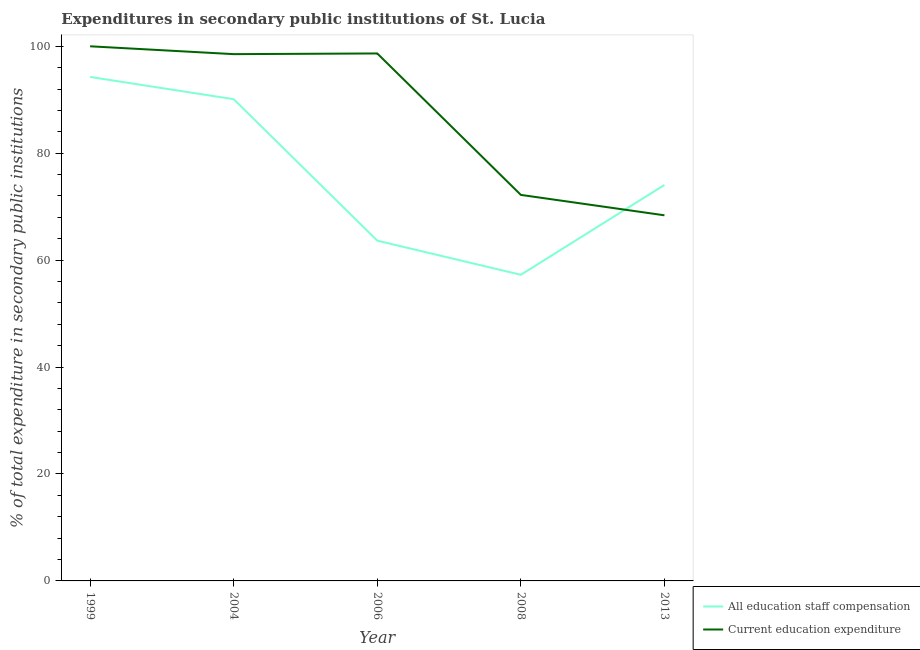How many different coloured lines are there?
Offer a very short reply. 2. Does the line corresponding to expenditure in education intersect with the line corresponding to expenditure in staff compensation?
Provide a succinct answer. Yes. What is the expenditure in education in 2008?
Your answer should be very brief. 72.2. Across all years, what is the maximum expenditure in staff compensation?
Offer a terse response. 94.27. Across all years, what is the minimum expenditure in staff compensation?
Provide a succinct answer. 57.26. In which year was the expenditure in education maximum?
Offer a terse response. 1999. What is the total expenditure in education in the graph?
Offer a terse response. 437.79. What is the difference between the expenditure in staff compensation in 1999 and that in 2013?
Provide a short and direct response. 20.2. What is the difference between the expenditure in education in 1999 and the expenditure in staff compensation in 2004?
Your answer should be very brief. 9.9. What is the average expenditure in staff compensation per year?
Your answer should be very brief. 75.87. In the year 2004, what is the difference between the expenditure in education and expenditure in staff compensation?
Provide a succinct answer. 8.43. What is the ratio of the expenditure in staff compensation in 1999 to that in 2013?
Make the answer very short. 1.27. Is the expenditure in staff compensation in 1999 less than that in 2013?
Keep it short and to the point. No. Is the difference between the expenditure in staff compensation in 1999 and 2008 greater than the difference between the expenditure in education in 1999 and 2008?
Give a very brief answer. Yes. What is the difference between the highest and the second highest expenditure in education?
Make the answer very short. 1.34. What is the difference between the highest and the lowest expenditure in staff compensation?
Your response must be concise. 37. Is the sum of the expenditure in education in 1999 and 2006 greater than the maximum expenditure in staff compensation across all years?
Your response must be concise. Yes. Is the expenditure in staff compensation strictly greater than the expenditure in education over the years?
Give a very brief answer. No. Is the expenditure in education strictly less than the expenditure in staff compensation over the years?
Make the answer very short. No. What is the difference between two consecutive major ticks on the Y-axis?
Offer a terse response. 20. Are the values on the major ticks of Y-axis written in scientific E-notation?
Offer a very short reply. No. Where does the legend appear in the graph?
Your response must be concise. Bottom right. How many legend labels are there?
Your response must be concise. 2. How are the legend labels stacked?
Your answer should be very brief. Vertical. What is the title of the graph?
Offer a very short reply. Expenditures in secondary public institutions of St. Lucia. Does "Adolescent fertility rate" appear as one of the legend labels in the graph?
Offer a very short reply. No. What is the label or title of the Y-axis?
Keep it short and to the point. % of total expenditure in secondary public institutions. What is the % of total expenditure in secondary public institutions of All education staff compensation in 1999?
Your answer should be very brief. 94.27. What is the % of total expenditure in secondary public institutions of All education staff compensation in 2004?
Your answer should be very brief. 90.1. What is the % of total expenditure in secondary public institutions in Current education expenditure in 2004?
Ensure brevity in your answer.  98.53. What is the % of total expenditure in secondary public institutions of All education staff compensation in 2006?
Your response must be concise. 63.64. What is the % of total expenditure in secondary public institutions of Current education expenditure in 2006?
Offer a very short reply. 98.66. What is the % of total expenditure in secondary public institutions of All education staff compensation in 2008?
Your answer should be compact. 57.26. What is the % of total expenditure in secondary public institutions in Current education expenditure in 2008?
Give a very brief answer. 72.2. What is the % of total expenditure in secondary public institutions in All education staff compensation in 2013?
Keep it short and to the point. 74.07. What is the % of total expenditure in secondary public institutions in Current education expenditure in 2013?
Your response must be concise. 68.39. Across all years, what is the maximum % of total expenditure in secondary public institutions in All education staff compensation?
Provide a succinct answer. 94.27. Across all years, what is the minimum % of total expenditure in secondary public institutions in All education staff compensation?
Ensure brevity in your answer.  57.26. Across all years, what is the minimum % of total expenditure in secondary public institutions in Current education expenditure?
Your response must be concise. 68.39. What is the total % of total expenditure in secondary public institutions in All education staff compensation in the graph?
Provide a succinct answer. 379.35. What is the total % of total expenditure in secondary public institutions in Current education expenditure in the graph?
Ensure brevity in your answer.  437.79. What is the difference between the % of total expenditure in secondary public institutions of All education staff compensation in 1999 and that in 2004?
Your answer should be compact. 4.16. What is the difference between the % of total expenditure in secondary public institutions of Current education expenditure in 1999 and that in 2004?
Keep it short and to the point. 1.47. What is the difference between the % of total expenditure in secondary public institutions of All education staff compensation in 1999 and that in 2006?
Offer a very short reply. 30.62. What is the difference between the % of total expenditure in secondary public institutions of Current education expenditure in 1999 and that in 2006?
Offer a terse response. 1.34. What is the difference between the % of total expenditure in secondary public institutions in All education staff compensation in 1999 and that in 2008?
Ensure brevity in your answer.  37. What is the difference between the % of total expenditure in secondary public institutions in Current education expenditure in 1999 and that in 2008?
Offer a very short reply. 27.8. What is the difference between the % of total expenditure in secondary public institutions of All education staff compensation in 1999 and that in 2013?
Provide a short and direct response. 20.2. What is the difference between the % of total expenditure in secondary public institutions in Current education expenditure in 1999 and that in 2013?
Ensure brevity in your answer.  31.61. What is the difference between the % of total expenditure in secondary public institutions in All education staff compensation in 2004 and that in 2006?
Your answer should be compact. 26.46. What is the difference between the % of total expenditure in secondary public institutions in Current education expenditure in 2004 and that in 2006?
Offer a terse response. -0.13. What is the difference between the % of total expenditure in secondary public institutions in All education staff compensation in 2004 and that in 2008?
Give a very brief answer. 32.84. What is the difference between the % of total expenditure in secondary public institutions of Current education expenditure in 2004 and that in 2008?
Offer a very short reply. 26.33. What is the difference between the % of total expenditure in secondary public institutions of All education staff compensation in 2004 and that in 2013?
Give a very brief answer. 16.04. What is the difference between the % of total expenditure in secondary public institutions of Current education expenditure in 2004 and that in 2013?
Provide a succinct answer. 30.14. What is the difference between the % of total expenditure in secondary public institutions of All education staff compensation in 2006 and that in 2008?
Offer a terse response. 6.38. What is the difference between the % of total expenditure in secondary public institutions of Current education expenditure in 2006 and that in 2008?
Make the answer very short. 26.46. What is the difference between the % of total expenditure in secondary public institutions in All education staff compensation in 2006 and that in 2013?
Your answer should be very brief. -10.42. What is the difference between the % of total expenditure in secondary public institutions in Current education expenditure in 2006 and that in 2013?
Your answer should be very brief. 30.27. What is the difference between the % of total expenditure in secondary public institutions in All education staff compensation in 2008 and that in 2013?
Your response must be concise. -16.8. What is the difference between the % of total expenditure in secondary public institutions of Current education expenditure in 2008 and that in 2013?
Provide a succinct answer. 3.82. What is the difference between the % of total expenditure in secondary public institutions of All education staff compensation in 1999 and the % of total expenditure in secondary public institutions of Current education expenditure in 2004?
Give a very brief answer. -4.27. What is the difference between the % of total expenditure in secondary public institutions of All education staff compensation in 1999 and the % of total expenditure in secondary public institutions of Current education expenditure in 2006?
Offer a terse response. -4.39. What is the difference between the % of total expenditure in secondary public institutions of All education staff compensation in 1999 and the % of total expenditure in secondary public institutions of Current education expenditure in 2008?
Your answer should be compact. 22.06. What is the difference between the % of total expenditure in secondary public institutions of All education staff compensation in 1999 and the % of total expenditure in secondary public institutions of Current education expenditure in 2013?
Your response must be concise. 25.88. What is the difference between the % of total expenditure in secondary public institutions of All education staff compensation in 2004 and the % of total expenditure in secondary public institutions of Current education expenditure in 2006?
Give a very brief answer. -8.56. What is the difference between the % of total expenditure in secondary public institutions of All education staff compensation in 2004 and the % of total expenditure in secondary public institutions of Current education expenditure in 2008?
Your response must be concise. 17.9. What is the difference between the % of total expenditure in secondary public institutions in All education staff compensation in 2004 and the % of total expenditure in secondary public institutions in Current education expenditure in 2013?
Make the answer very short. 21.72. What is the difference between the % of total expenditure in secondary public institutions in All education staff compensation in 2006 and the % of total expenditure in secondary public institutions in Current education expenditure in 2008?
Give a very brief answer. -8.56. What is the difference between the % of total expenditure in secondary public institutions of All education staff compensation in 2006 and the % of total expenditure in secondary public institutions of Current education expenditure in 2013?
Keep it short and to the point. -4.74. What is the difference between the % of total expenditure in secondary public institutions of All education staff compensation in 2008 and the % of total expenditure in secondary public institutions of Current education expenditure in 2013?
Offer a very short reply. -11.12. What is the average % of total expenditure in secondary public institutions in All education staff compensation per year?
Offer a very short reply. 75.87. What is the average % of total expenditure in secondary public institutions of Current education expenditure per year?
Offer a terse response. 87.56. In the year 1999, what is the difference between the % of total expenditure in secondary public institutions of All education staff compensation and % of total expenditure in secondary public institutions of Current education expenditure?
Keep it short and to the point. -5.73. In the year 2004, what is the difference between the % of total expenditure in secondary public institutions of All education staff compensation and % of total expenditure in secondary public institutions of Current education expenditure?
Offer a terse response. -8.43. In the year 2006, what is the difference between the % of total expenditure in secondary public institutions of All education staff compensation and % of total expenditure in secondary public institutions of Current education expenditure?
Keep it short and to the point. -35.02. In the year 2008, what is the difference between the % of total expenditure in secondary public institutions in All education staff compensation and % of total expenditure in secondary public institutions in Current education expenditure?
Make the answer very short. -14.94. In the year 2013, what is the difference between the % of total expenditure in secondary public institutions of All education staff compensation and % of total expenditure in secondary public institutions of Current education expenditure?
Provide a short and direct response. 5.68. What is the ratio of the % of total expenditure in secondary public institutions of All education staff compensation in 1999 to that in 2004?
Make the answer very short. 1.05. What is the ratio of the % of total expenditure in secondary public institutions in Current education expenditure in 1999 to that in 2004?
Provide a succinct answer. 1.01. What is the ratio of the % of total expenditure in secondary public institutions in All education staff compensation in 1999 to that in 2006?
Make the answer very short. 1.48. What is the ratio of the % of total expenditure in secondary public institutions of Current education expenditure in 1999 to that in 2006?
Your response must be concise. 1.01. What is the ratio of the % of total expenditure in secondary public institutions in All education staff compensation in 1999 to that in 2008?
Make the answer very short. 1.65. What is the ratio of the % of total expenditure in secondary public institutions in Current education expenditure in 1999 to that in 2008?
Your answer should be compact. 1.39. What is the ratio of the % of total expenditure in secondary public institutions in All education staff compensation in 1999 to that in 2013?
Make the answer very short. 1.27. What is the ratio of the % of total expenditure in secondary public institutions of Current education expenditure in 1999 to that in 2013?
Offer a terse response. 1.46. What is the ratio of the % of total expenditure in secondary public institutions in All education staff compensation in 2004 to that in 2006?
Make the answer very short. 1.42. What is the ratio of the % of total expenditure in secondary public institutions of All education staff compensation in 2004 to that in 2008?
Provide a short and direct response. 1.57. What is the ratio of the % of total expenditure in secondary public institutions in Current education expenditure in 2004 to that in 2008?
Your answer should be compact. 1.36. What is the ratio of the % of total expenditure in secondary public institutions of All education staff compensation in 2004 to that in 2013?
Ensure brevity in your answer.  1.22. What is the ratio of the % of total expenditure in secondary public institutions in Current education expenditure in 2004 to that in 2013?
Offer a very short reply. 1.44. What is the ratio of the % of total expenditure in secondary public institutions in All education staff compensation in 2006 to that in 2008?
Give a very brief answer. 1.11. What is the ratio of the % of total expenditure in secondary public institutions in Current education expenditure in 2006 to that in 2008?
Ensure brevity in your answer.  1.37. What is the ratio of the % of total expenditure in secondary public institutions in All education staff compensation in 2006 to that in 2013?
Make the answer very short. 0.86. What is the ratio of the % of total expenditure in secondary public institutions of Current education expenditure in 2006 to that in 2013?
Your answer should be very brief. 1.44. What is the ratio of the % of total expenditure in secondary public institutions in All education staff compensation in 2008 to that in 2013?
Provide a succinct answer. 0.77. What is the ratio of the % of total expenditure in secondary public institutions of Current education expenditure in 2008 to that in 2013?
Offer a very short reply. 1.06. What is the difference between the highest and the second highest % of total expenditure in secondary public institutions of All education staff compensation?
Offer a very short reply. 4.16. What is the difference between the highest and the second highest % of total expenditure in secondary public institutions in Current education expenditure?
Your answer should be compact. 1.34. What is the difference between the highest and the lowest % of total expenditure in secondary public institutions in All education staff compensation?
Ensure brevity in your answer.  37. What is the difference between the highest and the lowest % of total expenditure in secondary public institutions in Current education expenditure?
Your response must be concise. 31.61. 